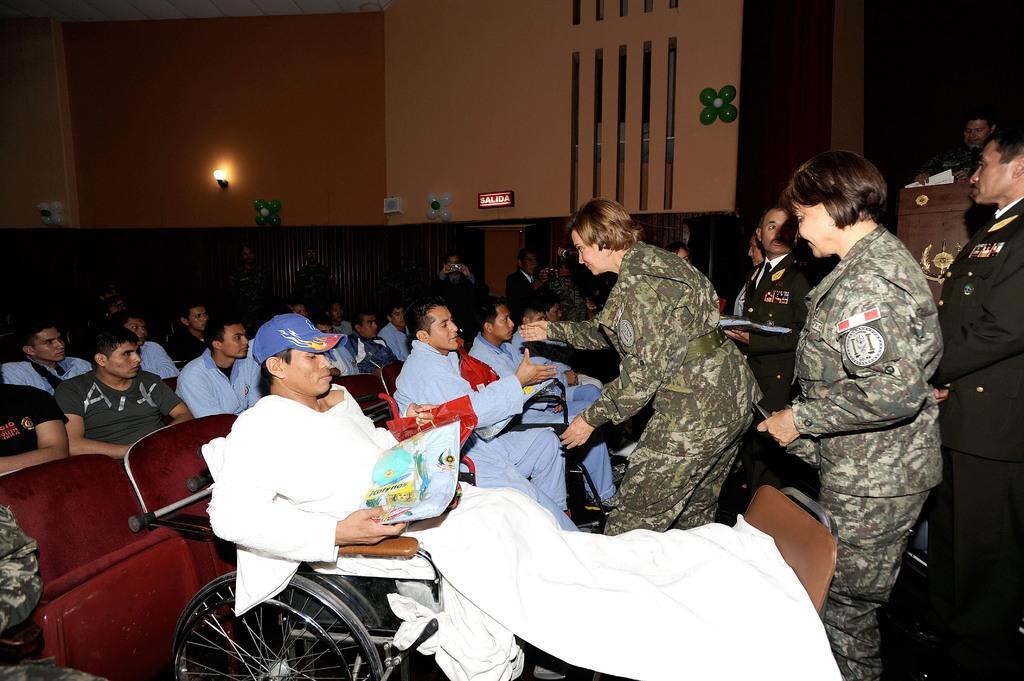Could you give a brief overview of what you see in this image? 2 female soldiers are standing at the right. Few people are standing behind them. There are people seated at the right. A person is sitting on a wheelchair wearing a white dress and a blue cap. He is holding something in his hands. There are balloons and a light at the back. 